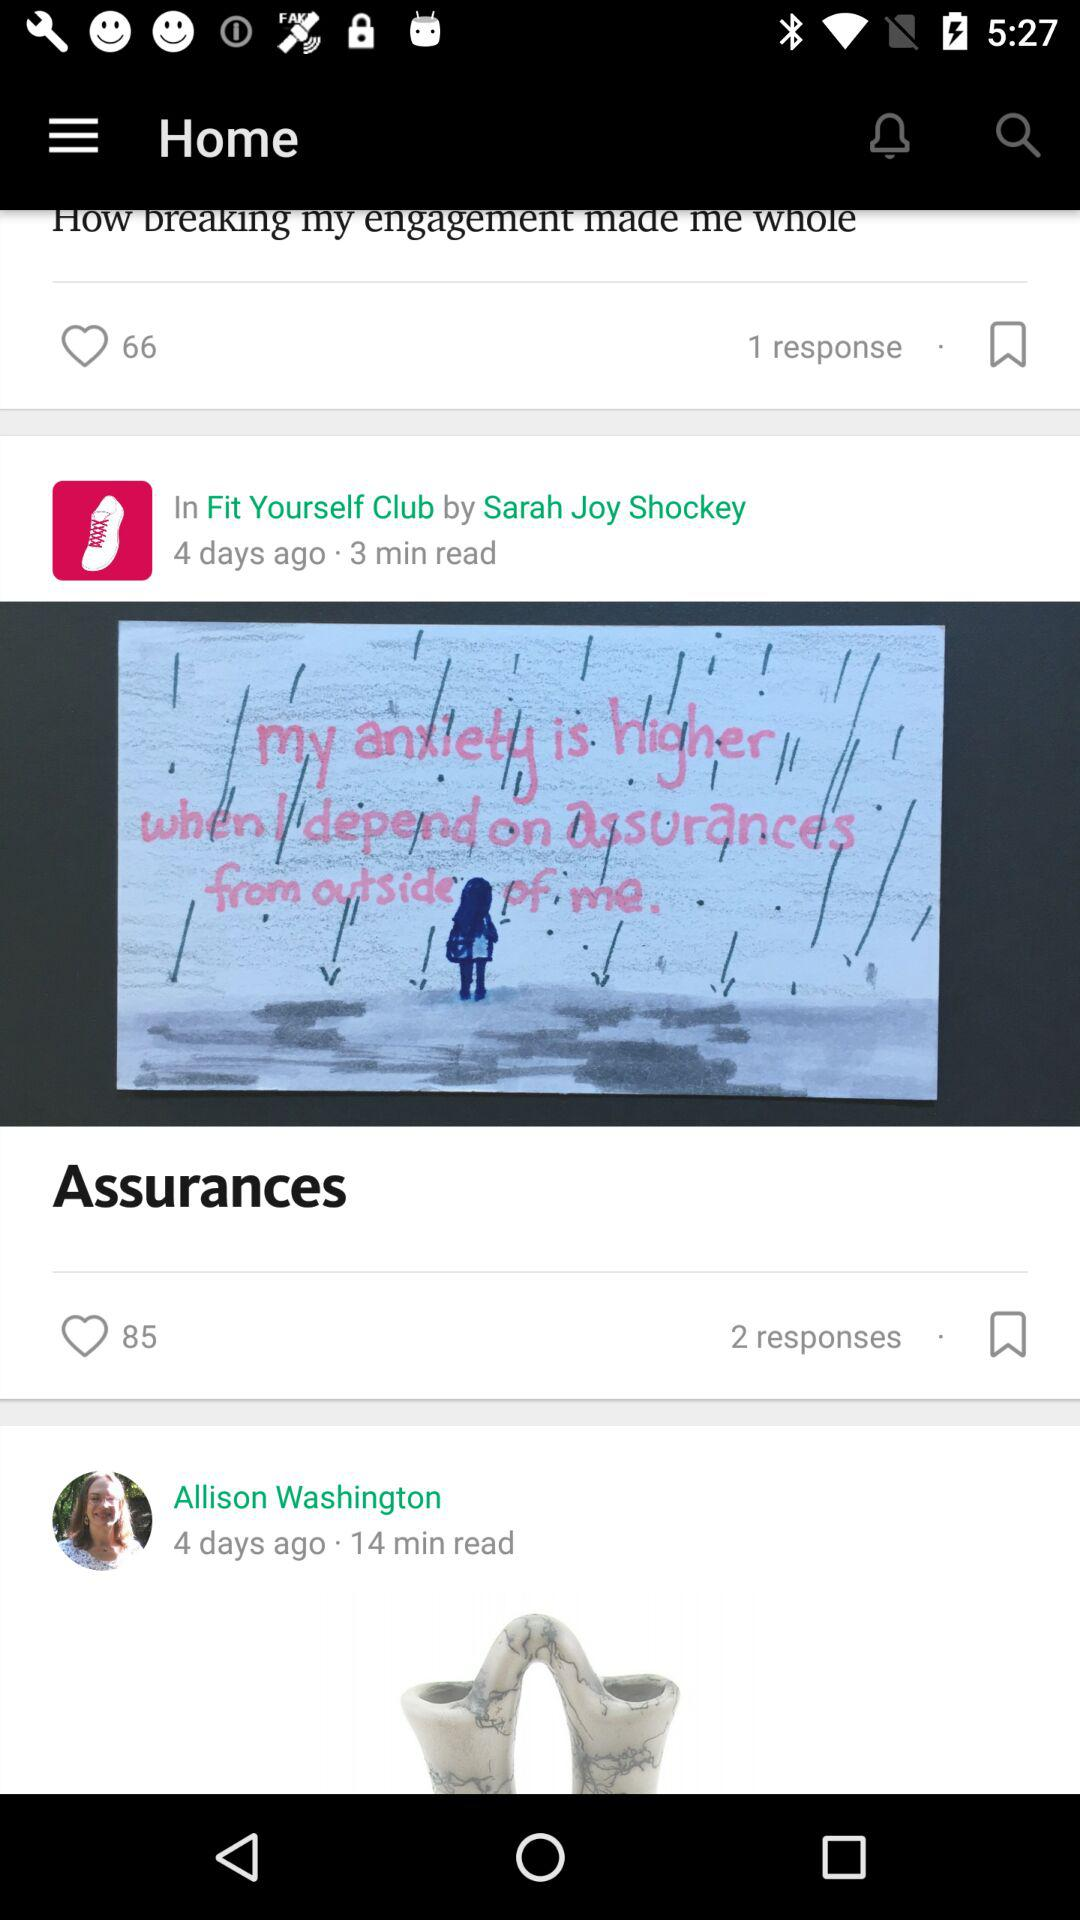How many more hearts does the Assurances article have than the How breaking my engagement made me whole article? 19 